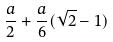Convert formula to latex. <formula><loc_0><loc_0><loc_500><loc_500>\frac { a } { 2 } + \frac { a } { 6 } ( \sqrt { 2 } - 1 )</formula> 